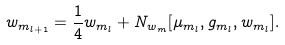<formula> <loc_0><loc_0><loc_500><loc_500>w _ { m _ { l + 1 } } = \frac { 1 } { 4 } w _ { m _ { l } } + N _ { w _ { m } } [ \mu _ { m _ { l } } , g _ { m _ { l } } , w _ { m _ { l } } ] .</formula> 